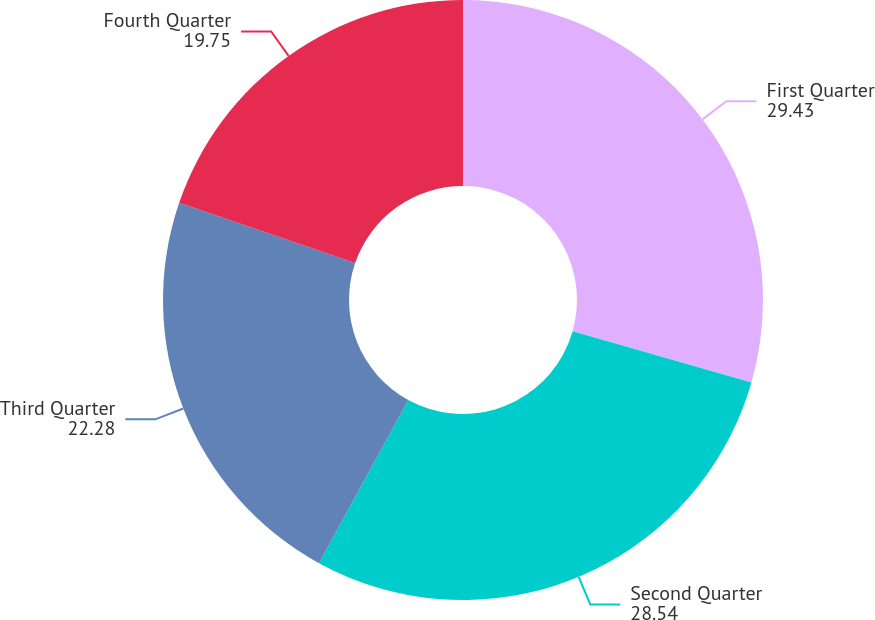<chart> <loc_0><loc_0><loc_500><loc_500><pie_chart><fcel>First Quarter<fcel>Second Quarter<fcel>Third Quarter<fcel>Fourth Quarter<nl><fcel>29.43%<fcel>28.54%<fcel>22.28%<fcel>19.75%<nl></chart> 